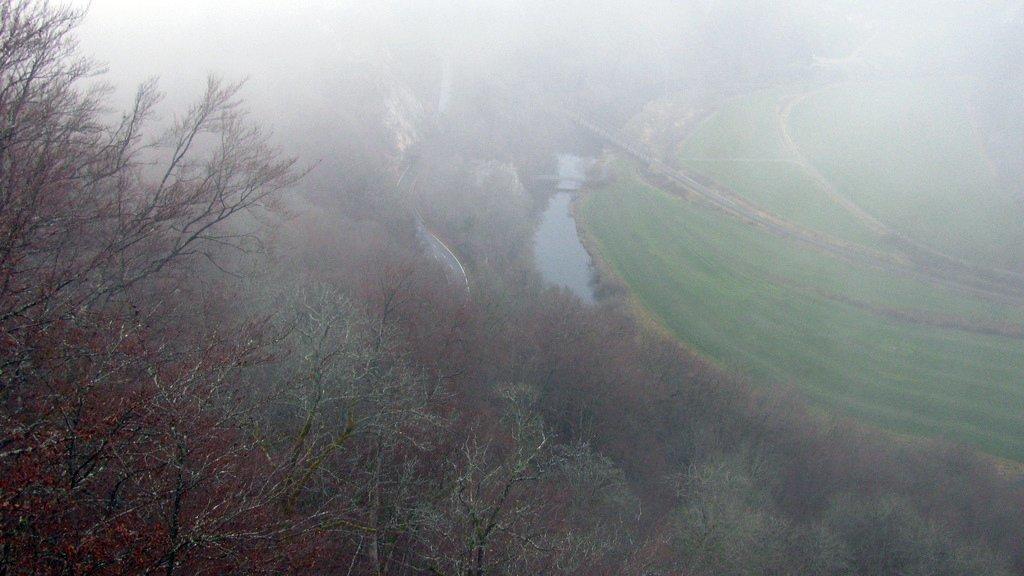Could you give a brief overview of what you see in this image? In the picture we can see some trees, water, road and on right side of the picture there is grass. 